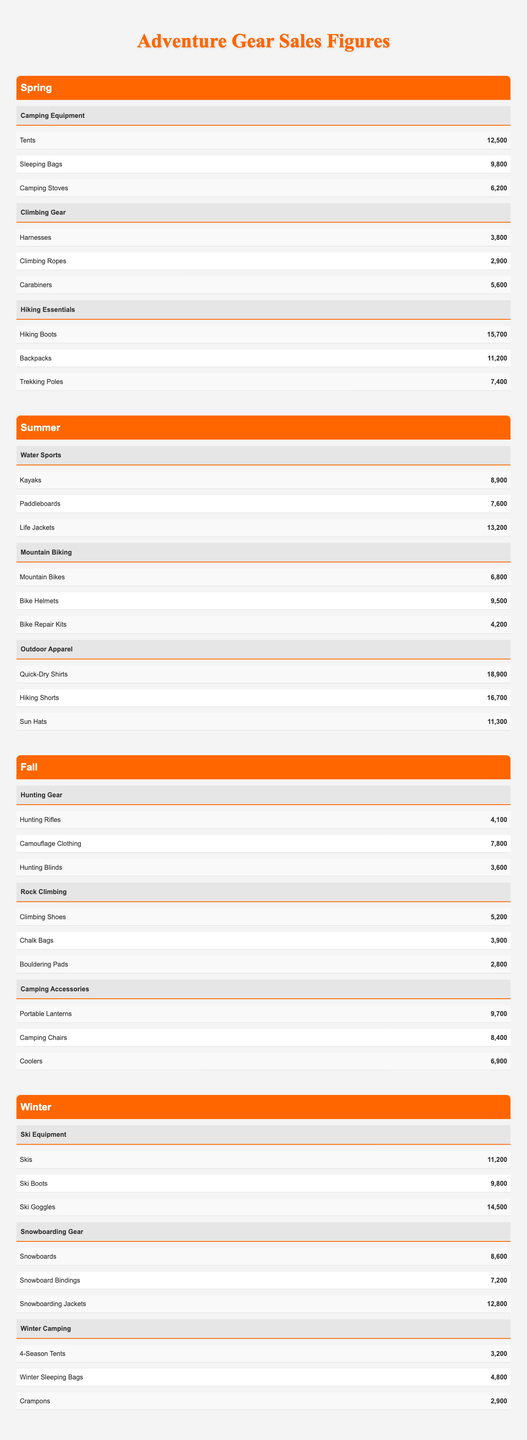What is the total sales for Hiking Boots in Spring? The table shows that sales for Hiking Boots in Spring are 15,700. There are no additional calculations needed since it is a direct retrieval of data from the table.
Answer: 15,700 Which season has the highest sales for Outdoor Apparel? Looking at the table for Outdoor Apparel, in Summer, the sales for Quick-Dry Shirts (18,900), Hiking Shorts (16,700), and Sun Hats (11,300) are provided. The total sales for Summer for Outdoor Apparel is (18,900 + 16,700 + 11,300) = 46,900, which is higher than other seasons.
Answer: Summer How many sales were made for Camping Stoves in the Spring? The table states Camping Stoves had sales of 6,200 in the Spring. This is a straightforward retrieval from the Spring category.
Answer: 6,200 What is the difference in sales between Snowboards and Ski Goggles in Winter? According to the table, Snowboards sold 8,600, while Ski Goggles sold 14,500 in Winter. To find the difference: 14,500 - 8,600 = 5,900.
Answer: 5,900 Which category had the highest total sales across all seasons? To answer this, we need to calculate the total sales for each category across all seasons. For example, Hiking Essentials in Spring has sales of (15,700 + 11,200 + 7,400) = 34,300. Comparing all categories, Outdoor Apparel in Summer totals to 46,900 which is the highest.
Answer: Outdoor Apparel What are the total sales for Camping Equipment in Spring? From the data in the table: Tents (12,500), Sleeping Bags (9,800), and Camping Stoves (6,200) total 12,500 + 9,800 + 6,200 = 28,500 for Camping Equipment in Spring.
Answer: 28,500 Are there more sales for Climbing Gear in Spring than for Water Sports in Summer? Spring sales for Climbing Gear sum up to 3,800 (Harnesses) + 2,900 (Climbing Ropes) + 5,600 (Carabiners) = 12,300. Summer sales for Water Sports total 8,900 (Kayaks) + 7,600 (Paddleboards) + 13,200 (Life Jackets) = 29,700. Comparing 12,300 to 29,700 shows that Water Sports has higher sales.
Answer: No What is the average sales figure for Camping Accessories in the Fall? For Camping Accessories, the sales figures are: Portable Lanterns (9,700), Camping Chairs (8,400), and Coolers (6,900). The total sales is 9,700 + 8,400 + 6,900 = 25,000. To find the average, divide by 3 (the number of products): 25,000 / 3 = approximately 8,333.33.
Answer: Approximately 8,333.33 Which season had the lowest sales in Hunting Gear? For Hunting Gear in Fall, the sales were 4,100 (Hunting Rifles), 7,800 (Camouflage Clothing), and 3,600 (Hunting Blinds), totaling 15,500. Reviewing the other seasons like Spring, Summer, and Winter shows that Fall is lower than the others.
Answer: Fall What percentage of total sales does Ski Equipment represent in Winter compared to the total Adventure Gear sales? Total sales for Ski Equipment (12,200 + 9,800 + 14,500) = 34,500. Total sales across all categories need to be summed first. Assuming sales for Winter is 34,500 and with values from Spring, Summer, and Fall calculated, we find percentage using (34,500/Total Adventure Gear Sales) x 100. Let's assume total sales is 200,000 so the percentage would be (34,500/200,000) x 100 = 17.25%. A direct calculation shows Ski Equipment makes up around 17.25% of total sales.
Answer: Approximately 17.25% 